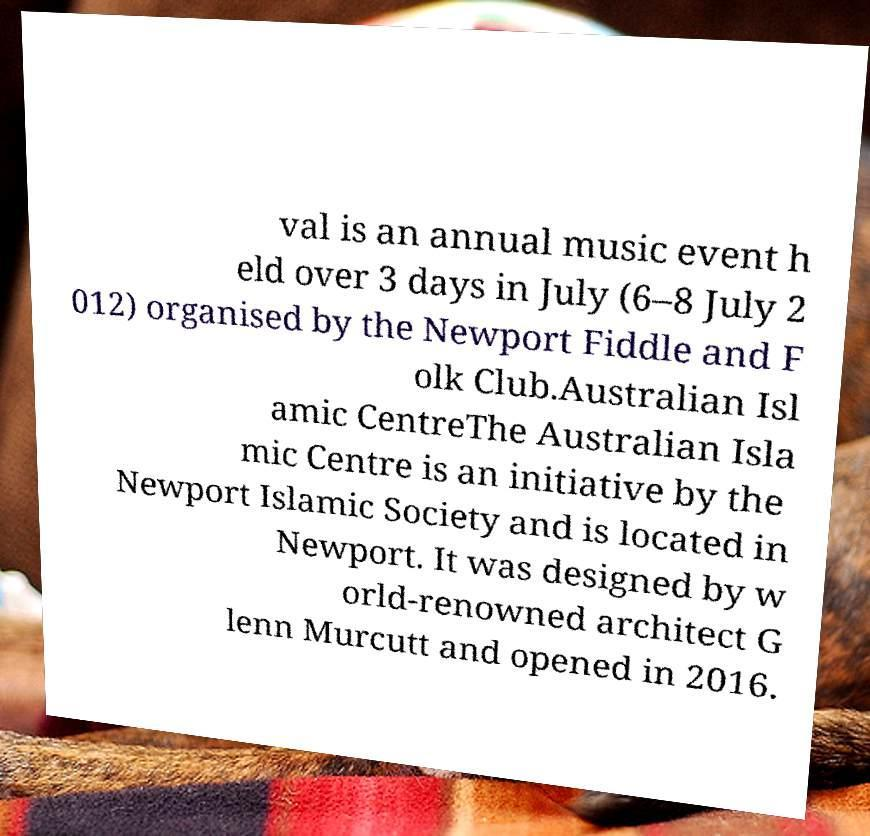Can you accurately transcribe the text from the provided image for me? val is an annual music event h eld over 3 days in July (6–8 July 2 012) organised by the Newport Fiddle and F olk Club.Australian Isl amic CentreThe Australian Isla mic Centre is an initiative by the Newport Islamic Society and is located in Newport. It was designed by w orld-renowned architect G lenn Murcutt and opened in 2016. 